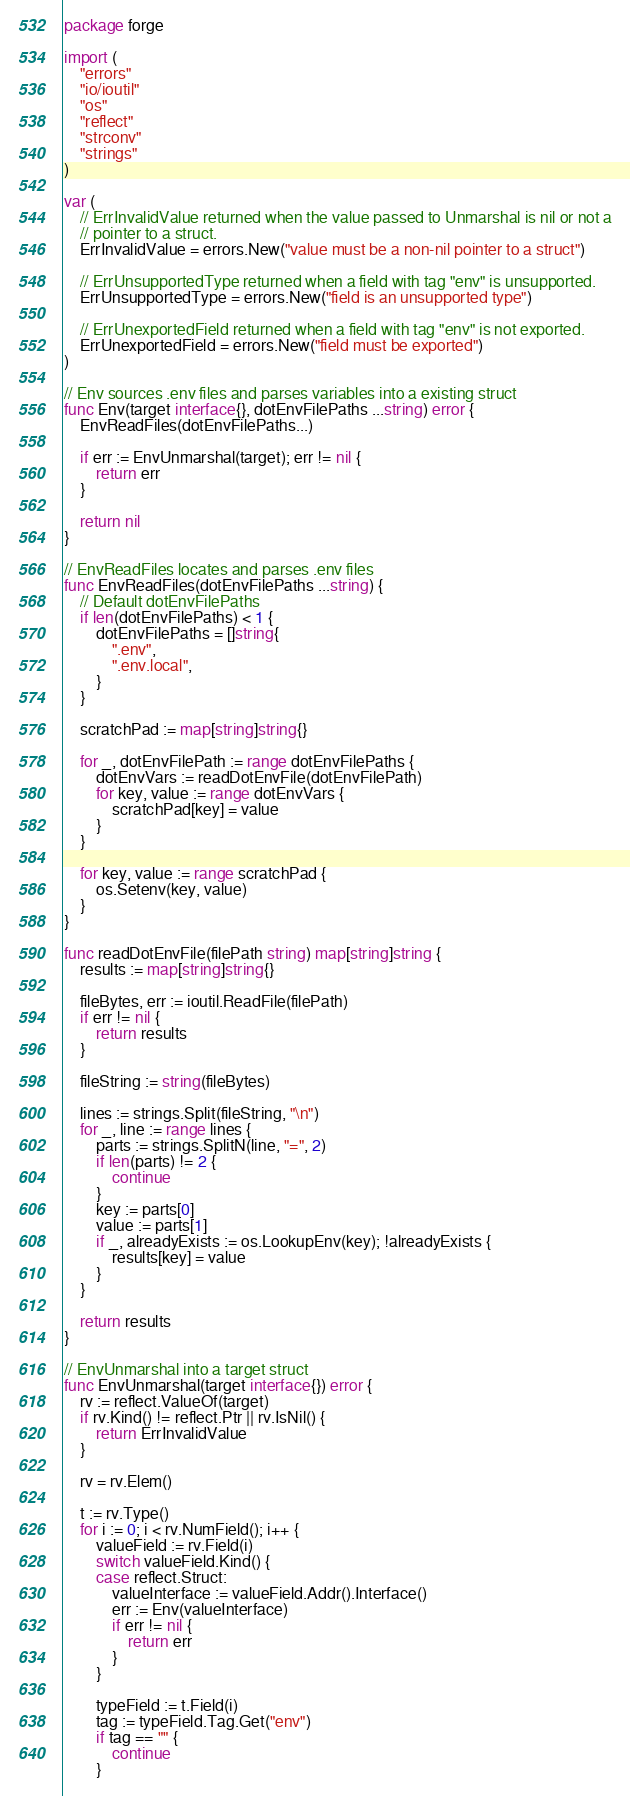Convert code to text. <code><loc_0><loc_0><loc_500><loc_500><_Go_>package forge

import (
	"errors"
	"io/ioutil"
	"os"
	"reflect"
	"strconv"
	"strings"
)

var (
	// ErrInvalidValue returned when the value passed to Unmarshal is nil or not a
	// pointer to a struct.
	ErrInvalidValue = errors.New("value must be a non-nil pointer to a struct")

	// ErrUnsupportedType returned when a field with tag "env" is unsupported.
	ErrUnsupportedType = errors.New("field is an unsupported type")

	// ErrUnexportedField returned when a field with tag "env" is not exported.
	ErrUnexportedField = errors.New("field must be exported")
)

// Env sources .env files and parses variables into a existing struct
func Env(target interface{}, dotEnvFilePaths ...string) error {
	EnvReadFiles(dotEnvFilePaths...)

	if err := EnvUnmarshal(target); err != nil {
		return err
	}

	return nil
}

// EnvReadFiles locates and parses .env files
func EnvReadFiles(dotEnvFilePaths ...string) {
	// Default dotEnvFilePaths
	if len(dotEnvFilePaths) < 1 {
		dotEnvFilePaths = []string{
			".env",
			".env.local",
		}
	}

	scratchPad := map[string]string{}

	for _, dotEnvFilePath := range dotEnvFilePaths {
		dotEnvVars := readDotEnvFile(dotEnvFilePath)
		for key, value := range dotEnvVars {
			scratchPad[key] = value
		}
	}

	for key, value := range scratchPad {
		os.Setenv(key, value)
	}
}

func readDotEnvFile(filePath string) map[string]string {
	results := map[string]string{}

	fileBytes, err := ioutil.ReadFile(filePath)
	if err != nil {
		return results
	}

	fileString := string(fileBytes)

	lines := strings.Split(fileString, "\n")
	for _, line := range lines {
		parts := strings.SplitN(line, "=", 2)
		if len(parts) != 2 {
			continue
		}
		key := parts[0]
		value := parts[1]
		if _, alreadyExists := os.LookupEnv(key); !alreadyExists {
			results[key] = value
		}
	}

	return results
}

// EnvUnmarshal into a target struct
func EnvUnmarshal(target interface{}) error {
	rv := reflect.ValueOf(target)
	if rv.Kind() != reflect.Ptr || rv.IsNil() {
		return ErrInvalidValue
	}

	rv = rv.Elem()

	t := rv.Type()
	for i := 0; i < rv.NumField(); i++ {
		valueField := rv.Field(i)
		switch valueField.Kind() {
		case reflect.Struct:
			valueInterface := valueField.Addr().Interface()
			err := Env(valueInterface)
			if err != nil {
				return err
			}
		}

		typeField := t.Field(i)
		tag := typeField.Tag.Get("env")
		if tag == "" {
			continue
		}
</code> 